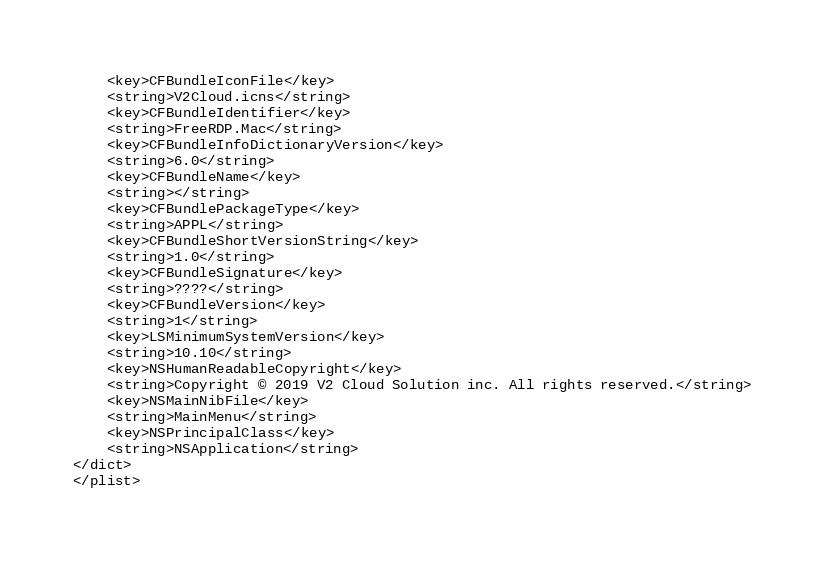<code> <loc_0><loc_0><loc_500><loc_500><_XML_>	<key>CFBundleIconFile</key>
	<string>V2Cloud.icns</string>
	<key>CFBundleIdentifier</key>
	<string>FreeRDP.Mac</string>
	<key>CFBundleInfoDictionaryVersion</key>
	<string>6.0</string>
	<key>CFBundleName</key>
	<string></string>
	<key>CFBundlePackageType</key>
	<string>APPL</string>
	<key>CFBundleShortVersionString</key>
	<string>1.0</string>
	<key>CFBundleSignature</key>
	<string>????</string>
	<key>CFBundleVersion</key>
	<string>1</string>
	<key>LSMinimumSystemVersion</key>
	<string>10.10</string>
	<key>NSHumanReadableCopyright</key>
	<string>Copyright © 2019 V2 Cloud Solution inc. All rights reserved.</string>
	<key>NSMainNibFile</key>
	<string>MainMenu</string>
	<key>NSPrincipalClass</key>
	<string>NSApplication</string>
</dict>
</plist>
</code> 